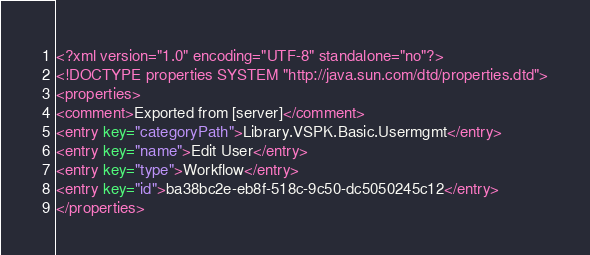<code> <loc_0><loc_0><loc_500><loc_500><_XML_><?xml version="1.0" encoding="UTF-8" standalone="no"?>
<!DOCTYPE properties SYSTEM "http://java.sun.com/dtd/properties.dtd">
<properties>
<comment>Exported from [server]</comment>
<entry key="categoryPath">Library.VSPK.Basic.Usermgmt</entry>
<entry key="name">Edit User</entry>
<entry key="type">Workflow</entry>
<entry key="id">ba38bc2e-eb8f-518c-9c50-dc5050245c12</entry>
</properties></code> 